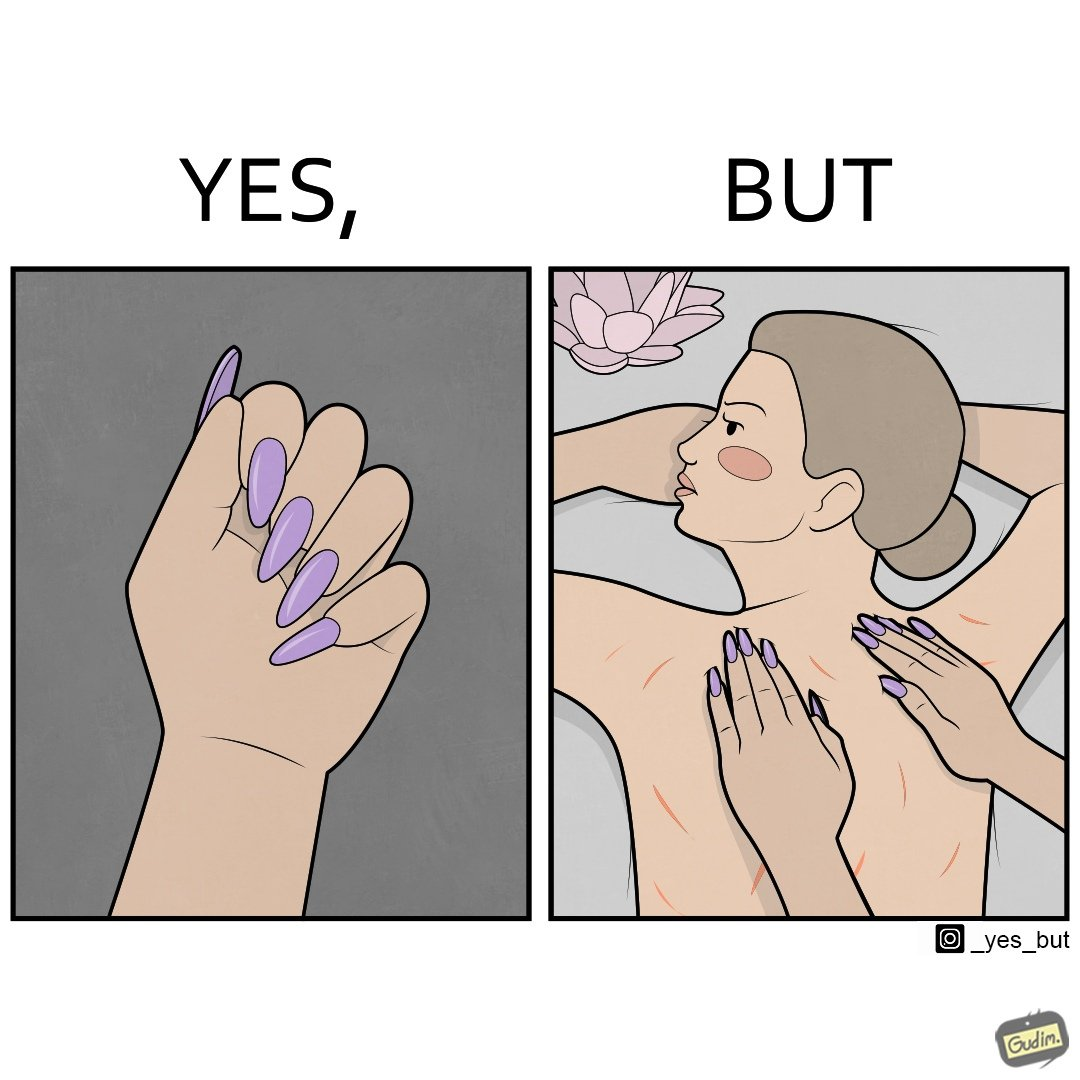What do you see in each half of this image? In the left part of the image: They are nails with nail polish In the right part of the image: It is an image of a woman with scratches on her back, possibly due to the nails of the masseuse digging into her back 